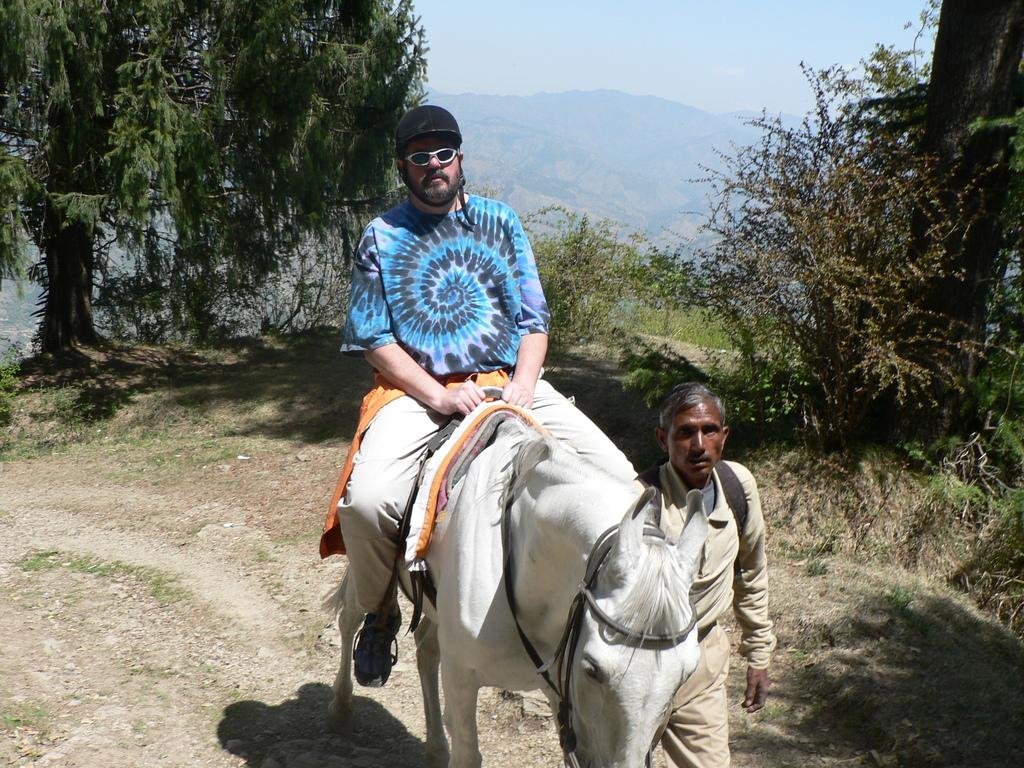What is the man in the image doing? The man is sitting on a horse in the image. Who is assisting the man on the horse? There is another man holding the horse in the image. What type of natural environment is visible in the image? Trees, plants, and mountains are visible in the image. What type of bulb is being used for teaching in the image? There is no bulb or teaching activity present in the image. How many steps are visible in the image? There are no steps visible in the image. 